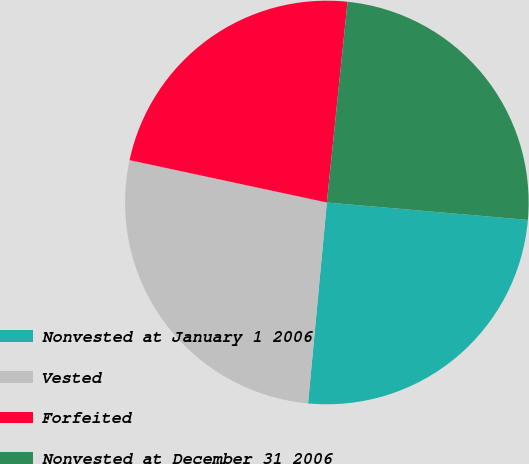<chart> <loc_0><loc_0><loc_500><loc_500><pie_chart><fcel>Nonvested at January 1 2006<fcel>Vested<fcel>Forfeited<fcel>Nonvested at December 31 2006<nl><fcel>25.11%<fcel>26.88%<fcel>23.27%<fcel>24.74%<nl></chart> 